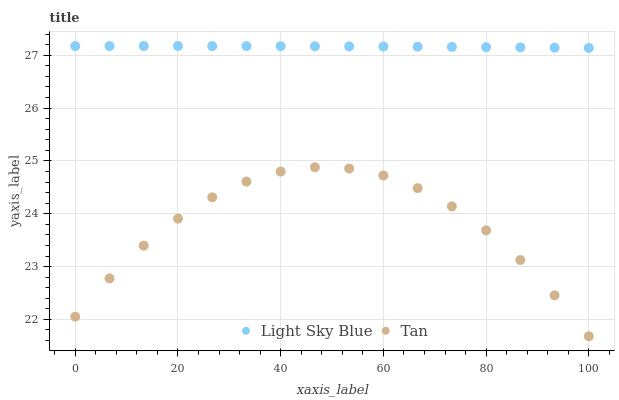Does Tan have the minimum area under the curve?
Answer yes or no. Yes. Does Light Sky Blue have the maximum area under the curve?
Answer yes or no. Yes. Does Light Sky Blue have the minimum area under the curve?
Answer yes or no. No. Is Light Sky Blue the smoothest?
Answer yes or no. Yes. Is Tan the roughest?
Answer yes or no. Yes. Is Light Sky Blue the roughest?
Answer yes or no. No. Does Tan have the lowest value?
Answer yes or no. Yes. Does Light Sky Blue have the lowest value?
Answer yes or no. No. Does Light Sky Blue have the highest value?
Answer yes or no. Yes. Is Tan less than Light Sky Blue?
Answer yes or no. Yes. Is Light Sky Blue greater than Tan?
Answer yes or no. Yes. Does Tan intersect Light Sky Blue?
Answer yes or no. No. 